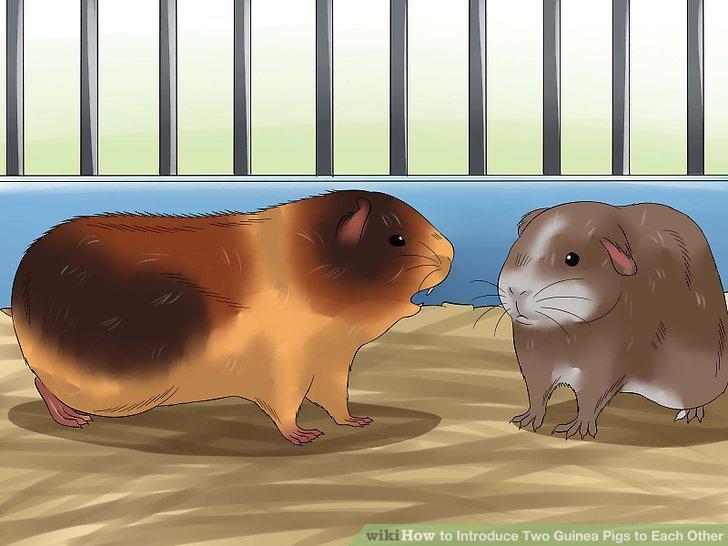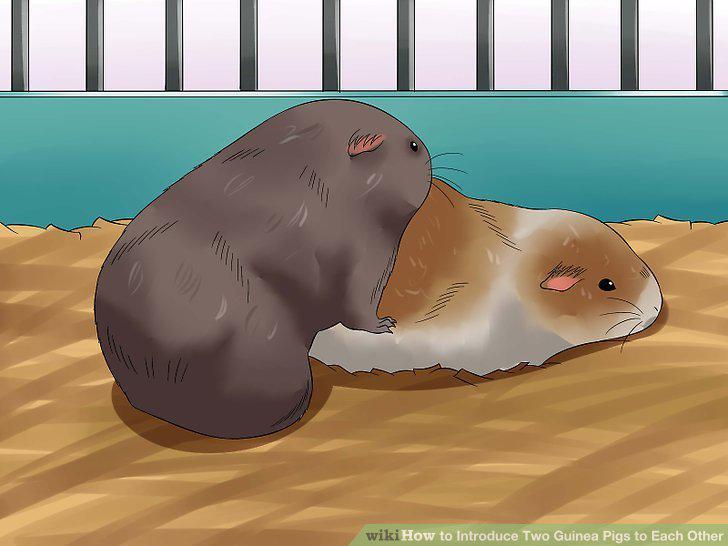The first image is the image on the left, the second image is the image on the right. For the images shown, is this caption "Each image shows two pet rodents on shredded-type bedding." true? Answer yes or no. No. 